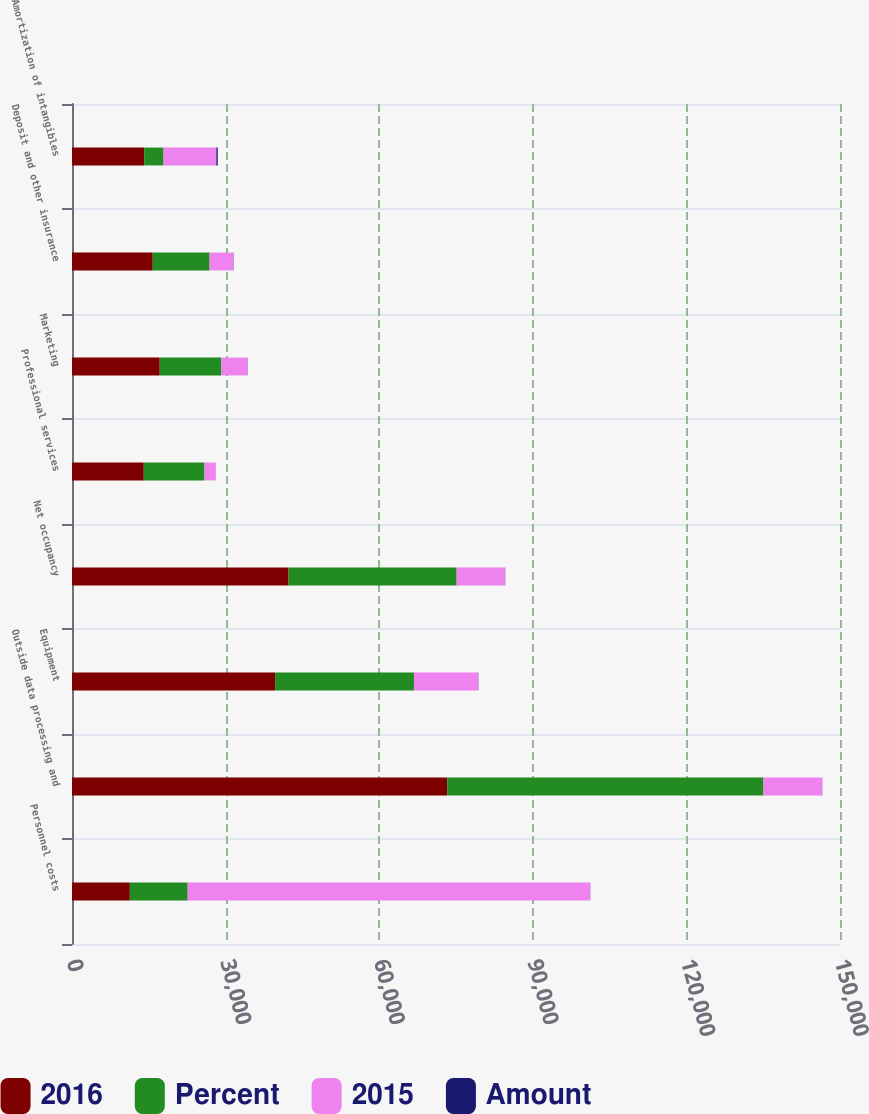Convert chart. <chart><loc_0><loc_0><loc_500><loc_500><stacked_bar_chart><ecel><fcel>Personnel costs<fcel>Outside data processing and<fcel>Equipment<fcel>Net occupancy<fcel>Professional services<fcel>Marketing<fcel>Deposit and other insurance<fcel>Amortization of intangibles<nl><fcel>2016<fcel>11297.5<fcel>73275<fcel>39666<fcel>42304<fcel>14024<fcel>17138<fcel>15772<fcel>14099<nl><fcel>Percent<fcel>11297.5<fcel>61785<fcel>27124<fcel>32829<fcel>11857<fcel>12035<fcel>11105<fcel>3788<nl><fcel>2015<fcel>78611<fcel>11490<fcel>12542<fcel>9475<fcel>2167<fcel>5103<fcel>4667<fcel>10311<nl><fcel>Amount<fcel>27<fcel>19<fcel>46<fcel>29<fcel>18<fcel>42<fcel>42<fcel>272<nl></chart> 